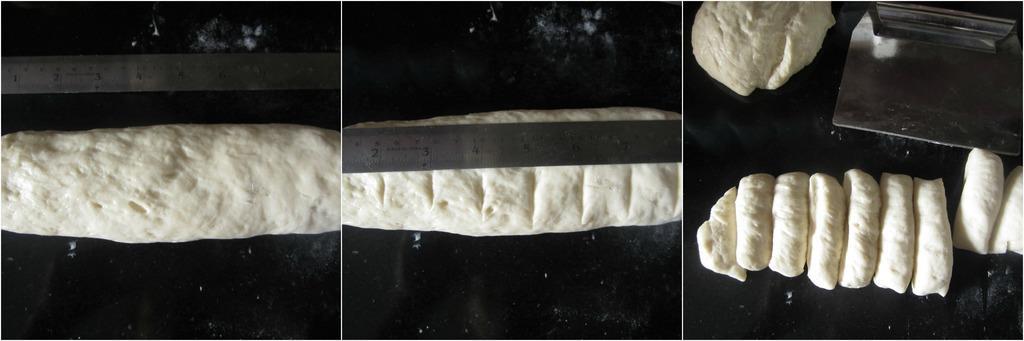Describe this image in one or two sentences. On the left side of the image there on the black surface there is a dough and a scale. In the middle of the image there is a dough with lines and scale on it. On the right side of the image there are few pieces of dough and a steel item on the surface. 